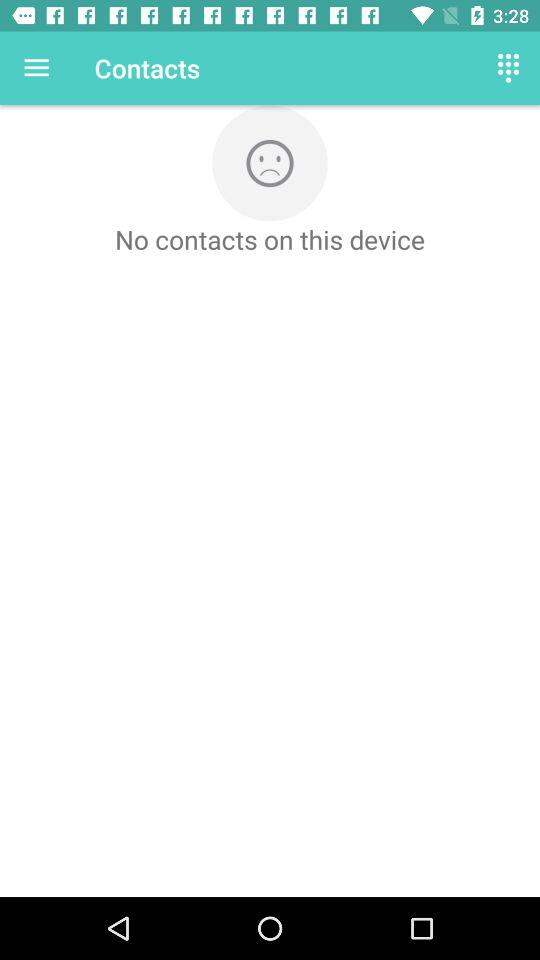How many sad faces are on the screen?
Answer the question using a single word or phrase. 1 